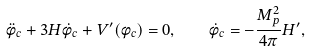<formula> <loc_0><loc_0><loc_500><loc_500>\ddot { \phi } _ { c } + 3 H \dot { \phi } _ { c } + V ^ { \prime } ( \phi _ { c } ) = 0 , \quad \dot { \phi } _ { c } = - \frac { M ^ { 2 } _ { p } } { 4 \pi } H ^ { \prime } ,</formula> 